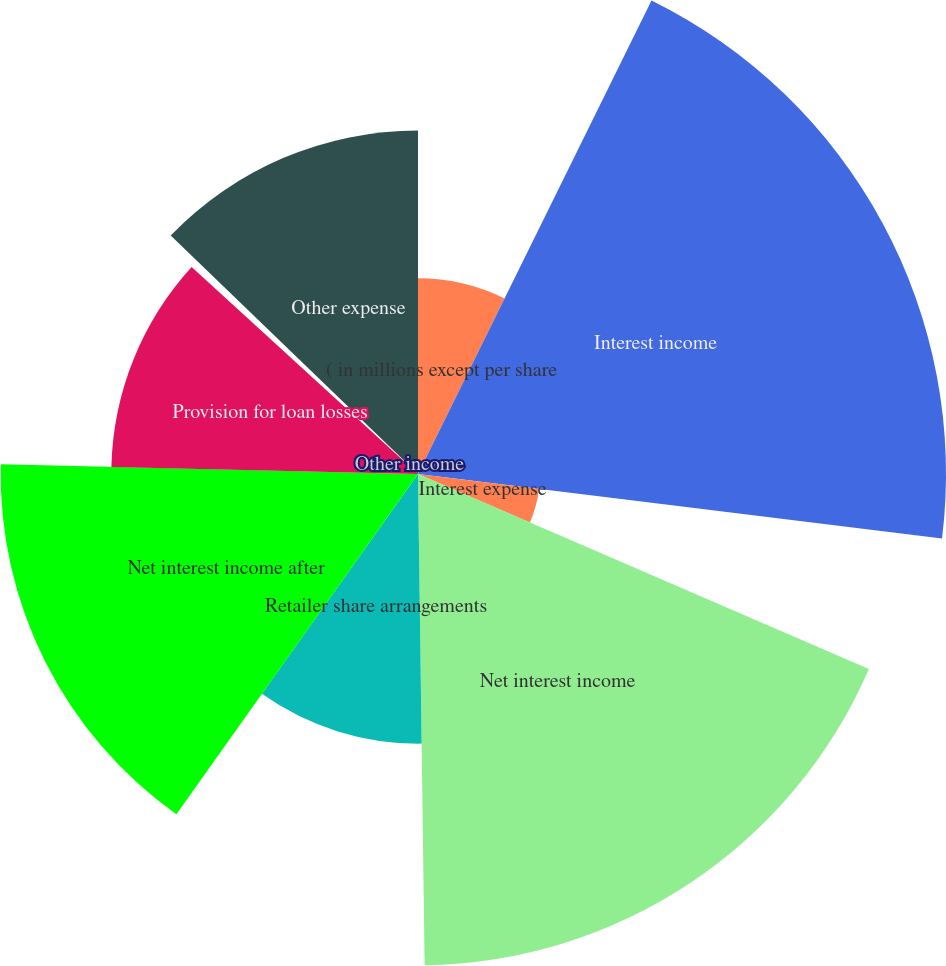Convert chart. <chart><loc_0><loc_0><loc_500><loc_500><pie_chart><fcel>( in millions except per share<fcel>Interest income<fcel>Interest expense<fcel>Net interest income<fcel>Retailer share arrangements<fcel>Net interest income after<fcel>Provision for loan losses<fcel>Other income<fcel>Other expense<nl><fcel>7.29%<fcel>19.66%<fcel>4.54%<fcel>18.29%<fcel>10.04%<fcel>15.54%<fcel>11.42%<fcel>0.42%<fcel>12.79%<nl></chart> 